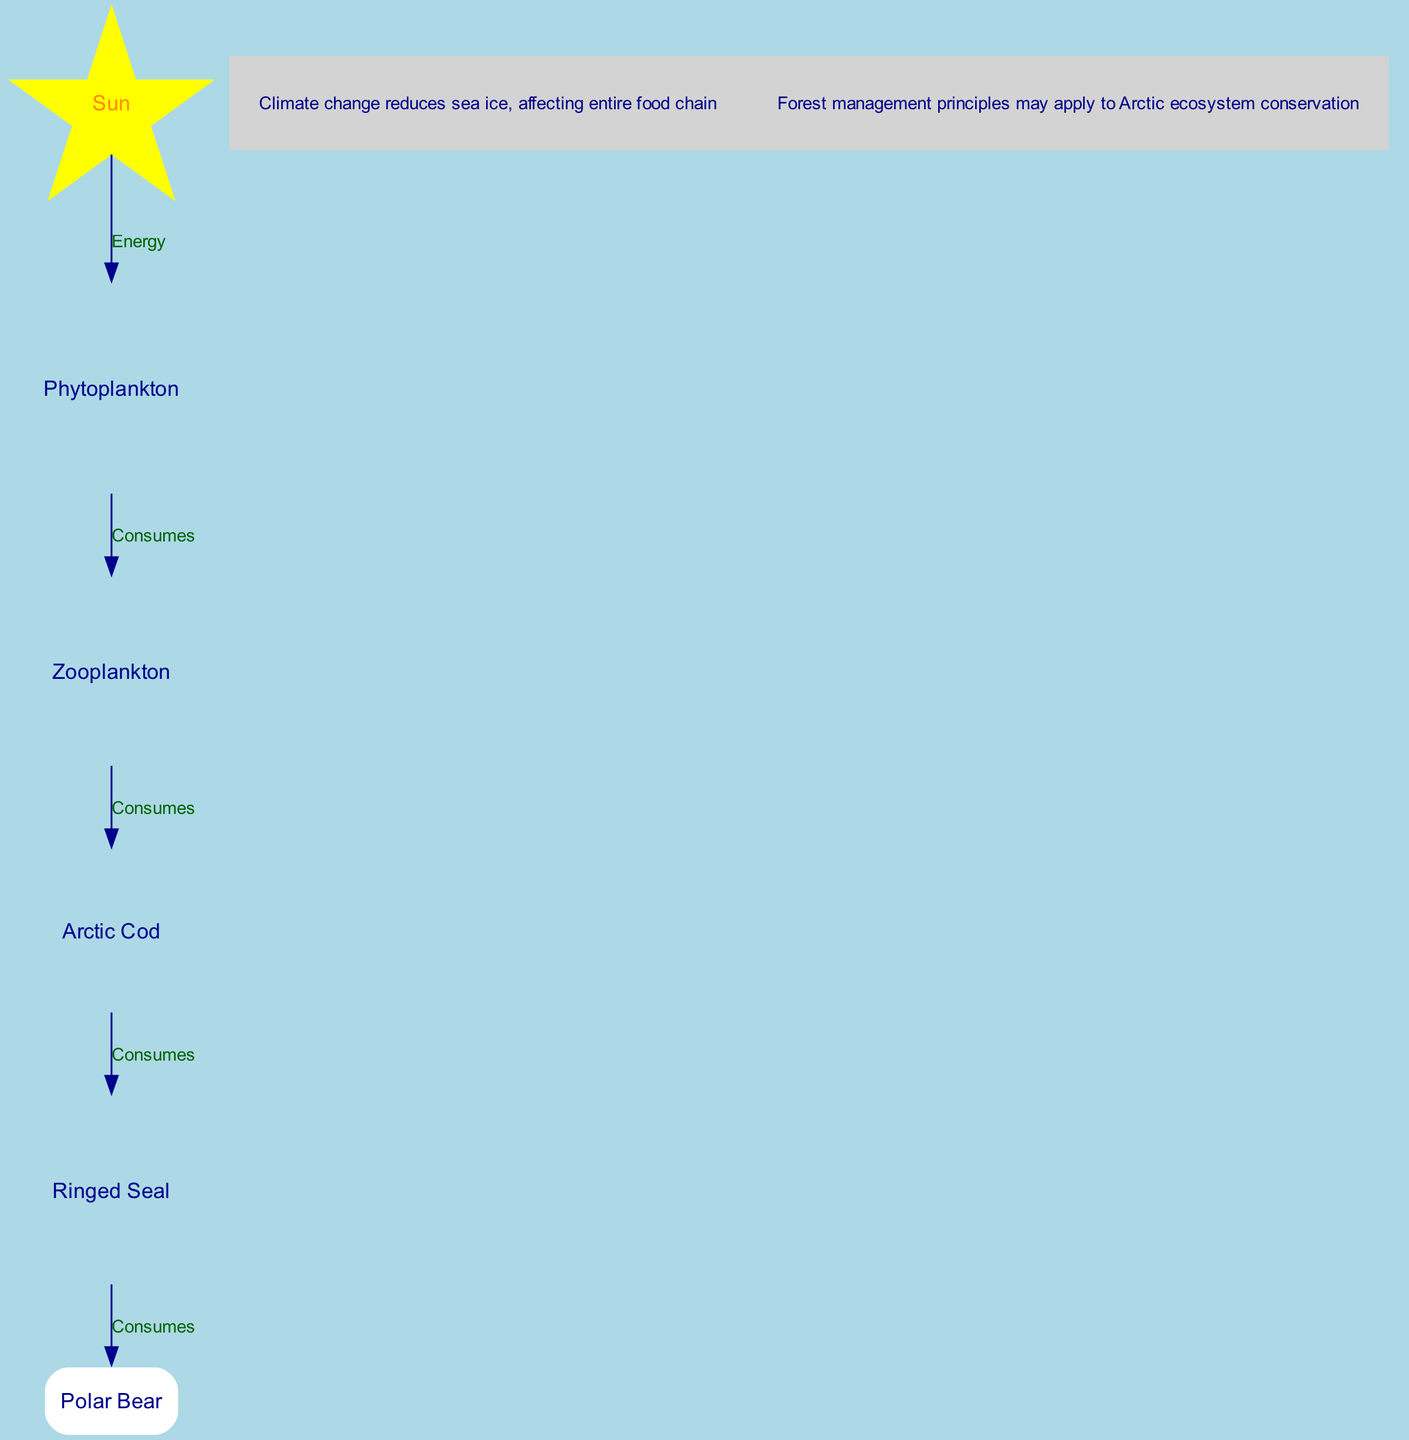What is the top node in the food chain? The top node in the food chain diagram represents the source of energy, which is the Sun.
Answer: Sun How many nodes are present in the food chain? To determine the number of nodes, we count each unique entity in the food chain, which includes the Sun, phytoplankton, zooplankton, arctic cod, ringed seal, and polar bear. There are six different entities.
Answer: 6 What type of relationship exists between phytoplankton and zooplankton? The relationship between phytoplankton and zooplankton is that zooplankton consumes phytoplankton, as indicated by the directed edge in the diagram.
Answer: Consumes Which organism is directly consumed by polar bears? The diagram shows that polar bears consume ringed seals, making the ringed seal the organism directly below the polar bear in the food chain.
Answer: Ringed Seal What impact does climate change have on the food chain? The note attached to the diagram indicates that climate change reduces sea ice, which affects the entire food chain by impacting the organisms that rely on sea ice for their survival and habitats.
Answer: Reduces sea ice How many consumption links are there in the food chain? By counting the directed edges that indicate a "consumes" relationship, we find that there are five links or consumption relationships connecting the various organisms in the food chain.
Answer: 5 What does the note about conservation suggest? The note indicates that principles from forest management could potentially be applied to the conservation of the Arctic ecosystem, hinting at a broader approach to managing ecosystem health.
Answer: Conservation principles What is the last organism in the food chain? The last organism in the food chain diagram that gets energy from others is the polar bear, positioned at the end of the consumption chain among the organisms listed.
Answer: Polar Bear What does the arrow from arctic cod to ringed seal represent? The arrow illustrates that arctic cod is consumed by ringed seals, establishing a direct predator-prey relationship between these two organisms in the food chain.
Answer: Consumes 